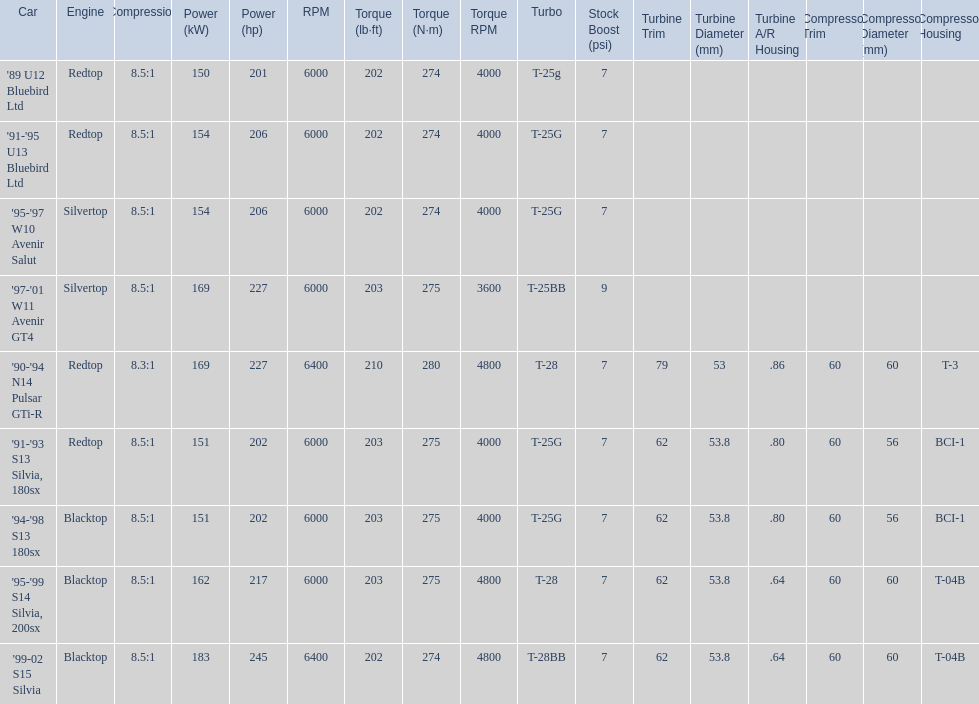What are all of the nissan cars? '89 U12 Bluebird Ltd, '91-'95 U13 Bluebird Ltd, '95-'97 W10 Avenir Salut, '97-'01 W11 Avenir GT4, '90-'94 N14 Pulsar GTi-R, '91-'93 S13 Silvia, 180sx, '94-'98 S13 180sx, '95-'99 S14 Silvia, 200sx, '99-02 S15 Silvia. Of these cars, which one is a '90-'94 n14 pulsar gti-r? '90-'94 N14 Pulsar GTi-R. What is the compression of this car? 8.3:1. Could you parse the entire table? {'header': ['Car', 'Engine', 'Compression', 'Power (kW)', 'Power (hp)', 'RPM', 'Torque (lb·ft)', 'Torque (N·m)', 'Torque RPM', 'Turbo', 'Stock Boost (psi)', 'Turbine Trim', 'Turbine Diameter (mm)', 'Turbine A/R Housing', 'Compressor Trim', 'Compressor Diameter (mm)', 'Compressor Housing'], 'rows': [["'89 U12 Bluebird Ltd", 'Redtop', '8.5:1', '150', '201', '6000', '202', '274', '4000', 'T-25g', '7', '', '', '', '', '', ''], ["'91-'95 U13 Bluebird Ltd", 'Redtop', '8.5:1', '154', '206', '6000', '202', '274', '4000', 'T-25G', '7', '', '', '', '', '', ''], ["'95-'97 W10 Avenir Salut", 'Silvertop', '8.5:1', '154', '206', '6000', '202', '274', '4000', 'T-25G', '7', '', '', '', '', '', ''], ["'97-'01 W11 Avenir GT4", 'Silvertop', '8.5:1', '169', '227', '6000', '203', '275', '3600', 'T-25BB', '9', '', '', '', '', '', ''], ["'90-'94 N14 Pulsar GTi-R", 'Redtop', '8.3:1', '169', '227', '6400', '210', '280', '4800', 'T-28', '7', '79', '53', '.86', '60', '60', 'T-3'], ["'91-'93 S13 Silvia, 180sx", 'Redtop', '8.5:1', '151', '202', '6000', '203', '275', '4000', 'T-25G', '7', '62', '53.8', '.80', '60', '56', 'BCI-1'], ["'94-'98 S13 180sx", 'Blacktop', '8.5:1', '151', '202', '6000', '203', '275', '4000', 'T-25G', '7', '62', '53.8', '.80', '60', '56', 'BCI-1'], ["'95-'99 S14 Silvia, 200sx", 'Blacktop', '8.5:1', '162', '217', '6000', '203', '275', '4800', 'T-28', '7', '62', '53.8', '.64', '60', '60', 'T-04B'], ["'99-02 S15 Silvia", 'Blacktop', '8.5:1', '183', '245', '6400', '202', '274', '4800', 'T-28BB', '7', '62', '53.8', '.64', '60', '60', 'T-04B']]} 